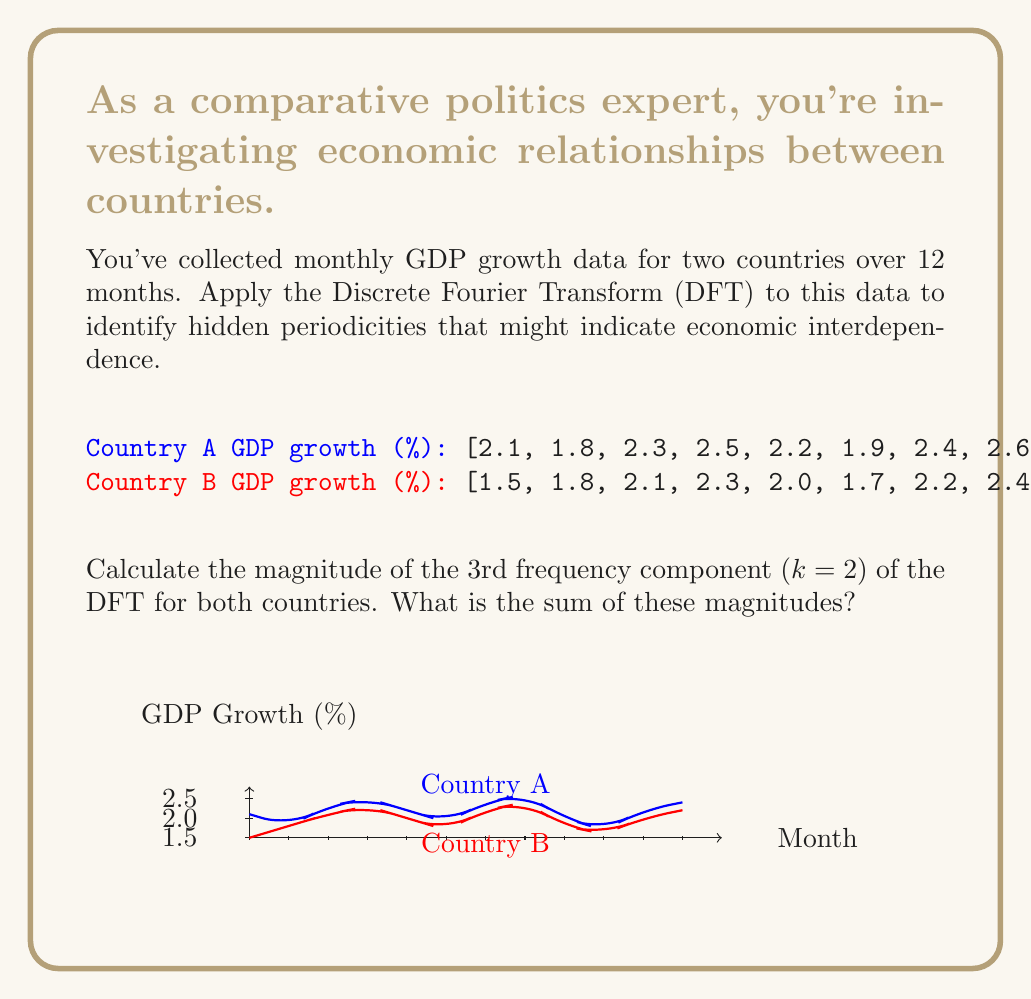Provide a solution to this math problem. To solve this problem, we'll follow these steps:

1) The Discrete Fourier Transform (DFT) for a sequence x[n] of length N is given by:

   $$X[k] = \sum_{n=0}^{N-1} x[n] e^{-i2\pi kn/N}$$

2) For k=2 (3rd frequency component) and N=12 (12 months), we need to calculate:

   $$X[2] = \sum_{n=0}^{11} x[n] e^{-i2\pi 2n/12}$$

3) Let's calculate this for Country A:

   $$X_A[2] = 2.1e^{0i} + 1.8e^{-i\pi/3} + 2.3e^{-i2\pi/3} + 2.5e^{-i\pi} + 2.2e^{-i4\pi/3} + 1.9e^{-i5\pi/3} + 2.4e^{-i2\pi} + 2.6e^{-i7\pi/3} + 2.0e^{-i8\pi/3} + 1.7e^{-i3\pi} + 2.2e^{-i10\pi/3} + 2.4e^{-i11\pi/3}$$

4) Simplifying and calculating:

   $$X_A[2] = -0.3 - 0.5196i$$

5) The magnitude is given by $|X_A[2]| = \sqrt{(-0.3)^2 + (-0.5196)^2} = 0.6$$

6) Now, let's do the same for Country B:

   $$X_B[2] = 1.5e^{0i} + 1.8e^{-i\pi/3} + 2.1e^{-i2\pi/3} + 2.3e^{-i\pi} + 2.0e^{-i4\pi/3} + 1.7e^{-i5\pi/3} + 2.2e^{-i2\pi} + 2.4e^{-i7\pi/3} + 1.8e^{-i8\pi/3} + 1.6e^{-i3\pi} + 2.0e^{-i10\pi/3} + 2.2e^{-i11\pi/3}$$

7) Simplifying and calculating:

   $$X_B[2] = -0.3 - 0.5196i$$

8) The magnitude is $|X_B[2]| = \sqrt{(-0.3)^2 + (-0.5196)^2} = 0.6$$

9) The sum of the magnitudes is $0.6 + 0.6 = 1.2$

This result suggests a similar 4-month periodicity in both countries' economic data, which could indicate economic interdependence.
Answer: 1.2 